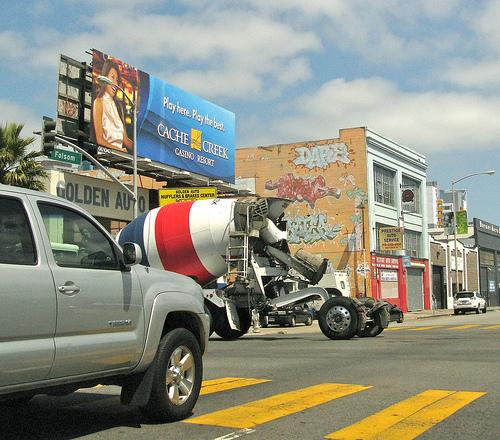What kind of art can be seen on the wall in the image? Graffiti art can be seen high up on the yellow wall. Is there a street light in the image? If so, describe its appearance. Yes, there is a tall white street light in the image. List and describe any signs visible in the image. There are several signs in the image: a large green sign by a pole, a sign saying "Golden Auto" on a building, a street sign on a light pole, and a stoplight on a light pole. What is the advertisement for on the large billboard above the road? The advertisement on the large billboard is for Cache Creek. What is the most prominent object on the road in the image? A large concrete mixer truck driving on the road is the most prominent object. Describe the large billboard visible in the image. The large billboard is blue and features a woman on a board, with the text "Cache Creek" visible on it. Count and describe the types of vehicles parked on the street in the image. There are two vehicles parked on the street: a white car and a white van parked in the distance. Identify the main vehicle in the image and its color. The main vehicle is a large concrete mixer truck with red, white, and blue colors. What is the pattern of the crosswalk seen in the image? The crosswalk pattern consists of thick yellow lines painted on the road. Describe the sky in the image and its characteristics. The sky in the image is blue and is sprinkled with fluffy white clouds. 